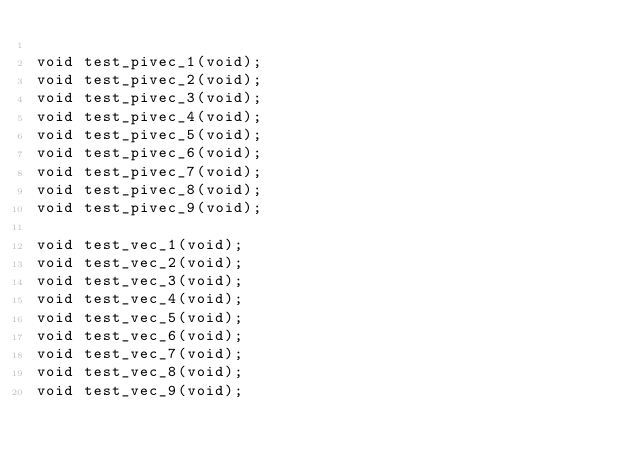<code> <loc_0><loc_0><loc_500><loc_500><_C_>
void test_pivec_1(void);
void test_pivec_2(void);
void test_pivec_3(void);
void test_pivec_4(void);
void test_pivec_5(void);
void test_pivec_6(void);
void test_pivec_7(void);
void test_pivec_8(void);
void test_pivec_9(void);

void test_vec_1(void);
void test_vec_2(void);
void test_vec_3(void);
void test_vec_4(void);
void test_vec_5(void);
void test_vec_6(void);
void test_vec_7(void);
void test_vec_8(void);
void test_vec_9(void);


</code> 